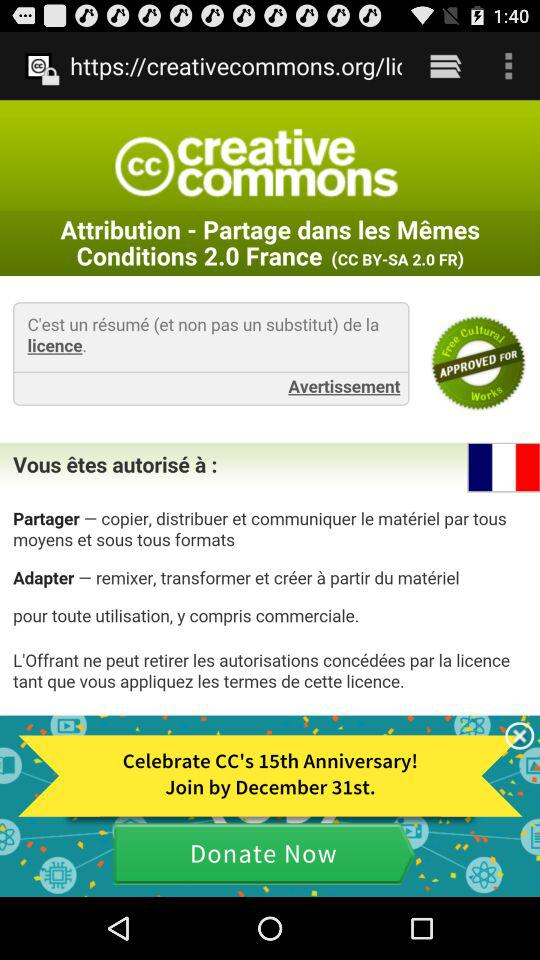By what date can it be joined? It can be joined by December 31st. 